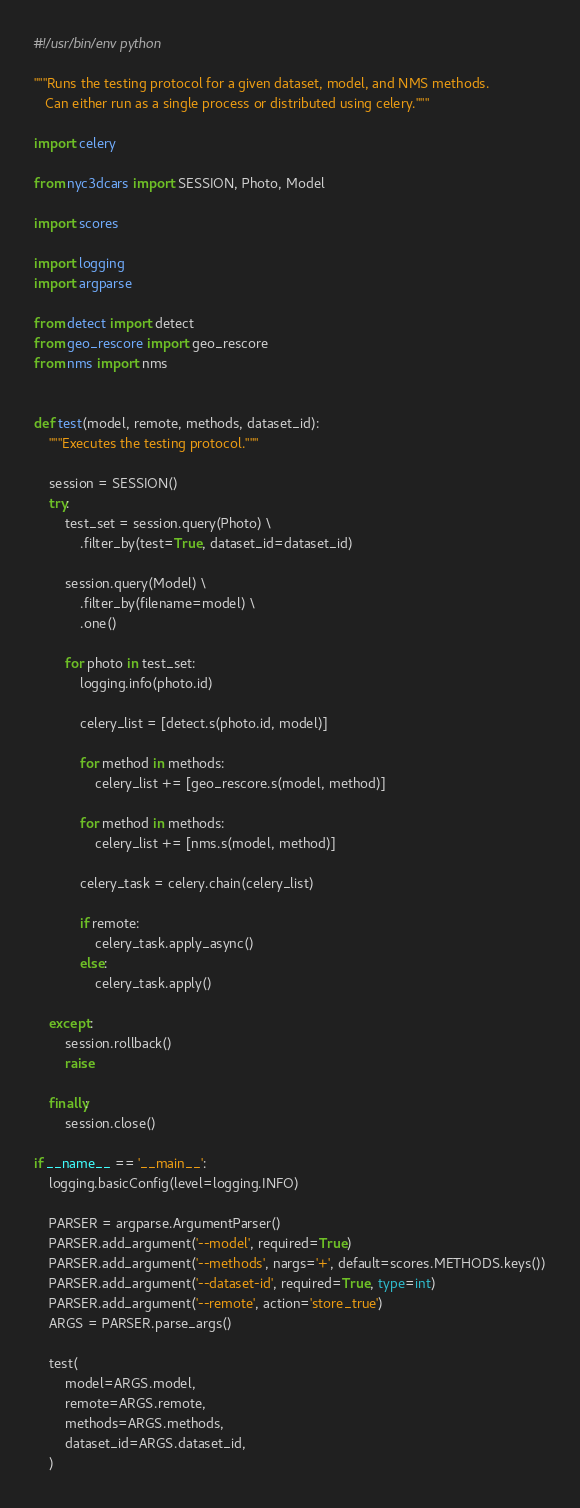<code> <loc_0><loc_0><loc_500><loc_500><_Python_>#!/usr/bin/env python

"""Runs the testing protocol for a given dataset, model, and NMS methods.
   Can either run as a single process or distributed using celery."""

import celery

from nyc3dcars import SESSION, Photo, Model

import scores

import logging
import argparse

from detect import detect
from geo_rescore import geo_rescore
from nms import nms


def test(model, remote, methods, dataset_id):
    """Executes the testing protocol."""

    session = SESSION()
    try:
        test_set = session.query(Photo) \
            .filter_by(test=True, dataset_id=dataset_id)

        session.query(Model) \
            .filter_by(filename=model) \
            .one()

        for photo in test_set:
            logging.info(photo.id)

            celery_list = [detect.s(photo.id, model)]

            for method in methods:
                celery_list += [geo_rescore.s(model, method)]

            for method in methods:
                celery_list += [nms.s(model, method)]

            celery_task = celery.chain(celery_list)

            if remote:
                celery_task.apply_async()
            else:
                celery_task.apply()

    except:
        session.rollback()
        raise

    finally:
        session.close()

if __name__ == '__main__':
    logging.basicConfig(level=logging.INFO)

    PARSER = argparse.ArgumentParser()
    PARSER.add_argument('--model', required=True)
    PARSER.add_argument('--methods', nargs='+', default=scores.METHODS.keys())
    PARSER.add_argument('--dataset-id', required=True, type=int)
    PARSER.add_argument('--remote', action='store_true')
    ARGS = PARSER.parse_args()

    test(
        model=ARGS.model,
        remote=ARGS.remote,
        methods=ARGS.methods,
        dataset_id=ARGS.dataset_id,
    )
</code> 